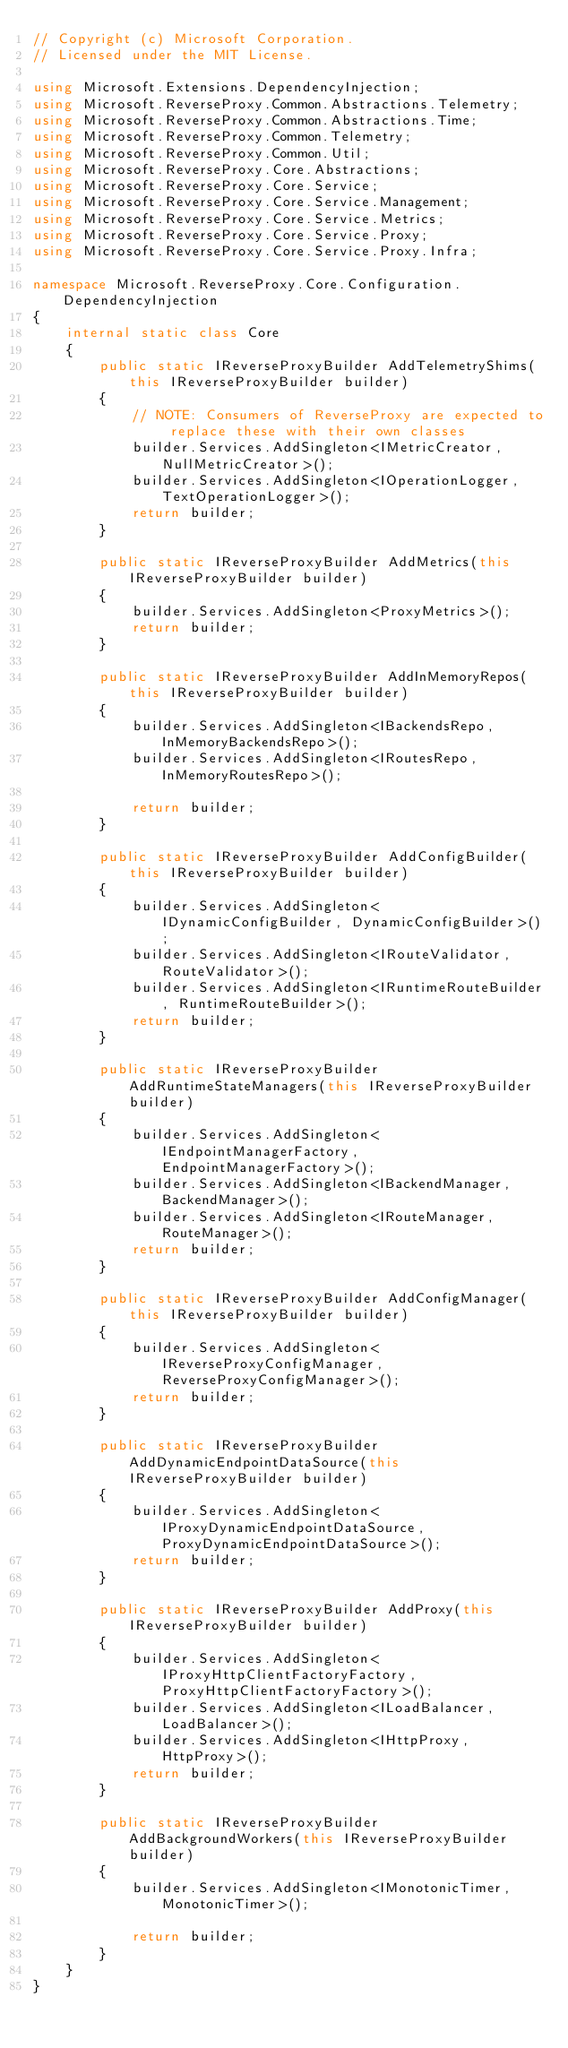Convert code to text. <code><loc_0><loc_0><loc_500><loc_500><_C#_>// Copyright (c) Microsoft Corporation.
// Licensed under the MIT License.

using Microsoft.Extensions.DependencyInjection;
using Microsoft.ReverseProxy.Common.Abstractions.Telemetry;
using Microsoft.ReverseProxy.Common.Abstractions.Time;
using Microsoft.ReverseProxy.Common.Telemetry;
using Microsoft.ReverseProxy.Common.Util;
using Microsoft.ReverseProxy.Core.Abstractions;
using Microsoft.ReverseProxy.Core.Service;
using Microsoft.ReverseProxy.Core.Service.Management;
using Microsoft.ReverseProxy.Core.Service.Metrics;
using Microsoft.ReverseProxy.Core.Service.Proxy;
using Microsoft.ReverseProxy.Core.Service.Proxy.Infra;

namespace Microsoft.ReverseProxy.Core.Configuration.DependencyInjection
{
    internal static class Core
    {
        public static IReverseProxyBuilder AddTelemetryShims(this IReverseProxyBuilder builder)
        {
            // NOTE: Consumers of ReverseProxy are expected to replace these with their own classes
            builder.Services.AddSingleton<IMetricCreator, NullMetricCreator>();
            builder.Services.AddSingleton<IOperationLogger, TextOperationLogger>();
            return builder;
        }

        public static IReverseProxyBuilder AddMetrics(this IReverseProxyBuilder builder)
        {
            builder.Services.AddSingleton<ProxyMetrics>();
            return builder;
        }

        public static IReverseProxyBuilder AddInMemoryRepos(this IReverseProxyBuilder builder)
        {
            builder.Services.AddSingleton<IBackendsRepo, InMemoryBackendsRepo>();
            builder.Services.AddSingleton<IRoutesRepo, InMemoryRoutesRepo>();

            return builder;
        }

        public static IReverseProxyBuilder AddConfigBuilder(this IReverseProxyBuilder builder)
        {
            builder.Services.AddSingleton<IDynamicConfigBuilder, DynamicConfigBuilder>();
            builder.Services.AddSingleton<IRouteValidator, RouteValidator>();
            builder.Services.AddSingleton<IRuntimeRouteBuilder, RuntimeRouteBuilder>();
            return builder;
        }

        public static IReverseProxyBuilder AddRuntimeStateManagers(this IReverseProxyBuilder builder)
        {
            builder.Services.AddSingleton<IEndpointManagerFactory, EndpointManagerFactory>();
            builder.Services.AddSingleton<IBackendManager, BackendManager>();
            builder.Services.AddSingleton<IRouteManager, RouteManager>();
            return builder;
        }

        public static IReverseProxyBuilder AddConfigManager(this IReverseProxyBuilder builder)
        {
            builder.Services.AddSingleton<IReverseProxyConfigManager, ReverseProxyConfigManager>();
            return builder;
        }

        public static IReverseProxyBuilder AddDynamicEndpointDataSource(this IReverseProxyBuilder builder)
        {
            builder.Services.AddSingleton<IProxyDynamicEndpointDataSource, ProxyDynamicEndpointDataSource>();
            return builder;
        }

        public static IReverseProxyBuilder AddProxy(this IReverseProxyBuilder builder)
        {
            builder.Services.AddSingleton<IProxyHttpClientFactoryFactory, ProxyHttpClientFactoryFactory>();
            builder.Services.AddSingleton<ILoadBalancer, LoadBalancer>();
            builder.Services.AddSingleton<IHttpProxy, HttpProxy>();
            return builder;
        }

        public static IReverseProxyBuilder AddBackgroundWorkers(this IReverseProxyBuilder builder)
        {
            builder.Services.AddSingleton<IMonotonicTimer, MonotonicTimer>();

            return builder;
        }
    }
}
</code> 